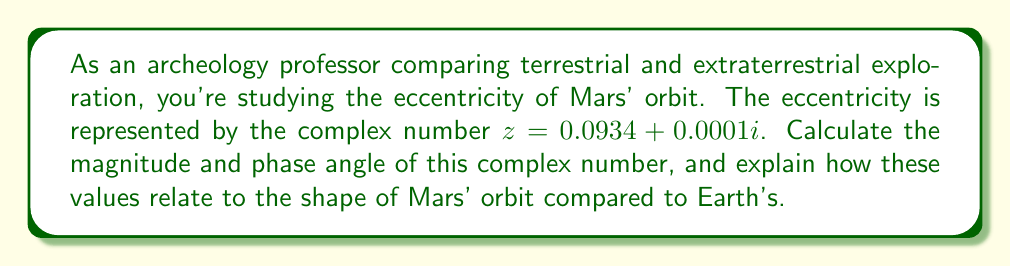Could you help me with this problem? To analyze the complex number $z = 0.0934 + 0.0001i$ representing Mars' orbital eccentricity:

1. Magnitude calculation:
   The magnitude of a complex number $z = a + bi$ is given by $|z| = \sqrt{a^2 + b^2}$.
   
   $$|z| = \sqrt{(0.0934)^2 + (0.0001)^2} = \sqrt{0.008723 + 0.00000001} \approx 0.0934$$

2. Phase angle calculation:
   The phase angle $\theta$ is given by $\theta = \tan^{-1}(\frac{b}{a})$.
   
   $$\theta = \tan^{-1}(\frac{0.0001}{0.0934}) \approx 0.0614 \text{ radians} \approx 3.52°$$

3. Interpretation:
   - The magnitude (0.0934) represents the eccentricity of Mars' orbit. This value indicates how much the orbit deviates from a perfect circle (0 eccentricity).
   - Earth's orbital eccentricity is approximately 0.0167, so Mars' orbit is more elliptical.
   - The phase angle (3.52°) represents a slight rotation of the orbit's major axis relative to a reference direction.

In terrestrial terms, this would be similar to studying the shape of ancient circular structures like Stonehenge, where slight deviations from a perfect circle might indicate intentional design or environmental factors affecting construction.
Answer: Magnitude: $|z| \approx 0.0934$
Phase angle: $\theta \approx 3.52°$

Mars' orbit is more eccentric than Earth's, with its eccentricity being about 5.59 times greater. 